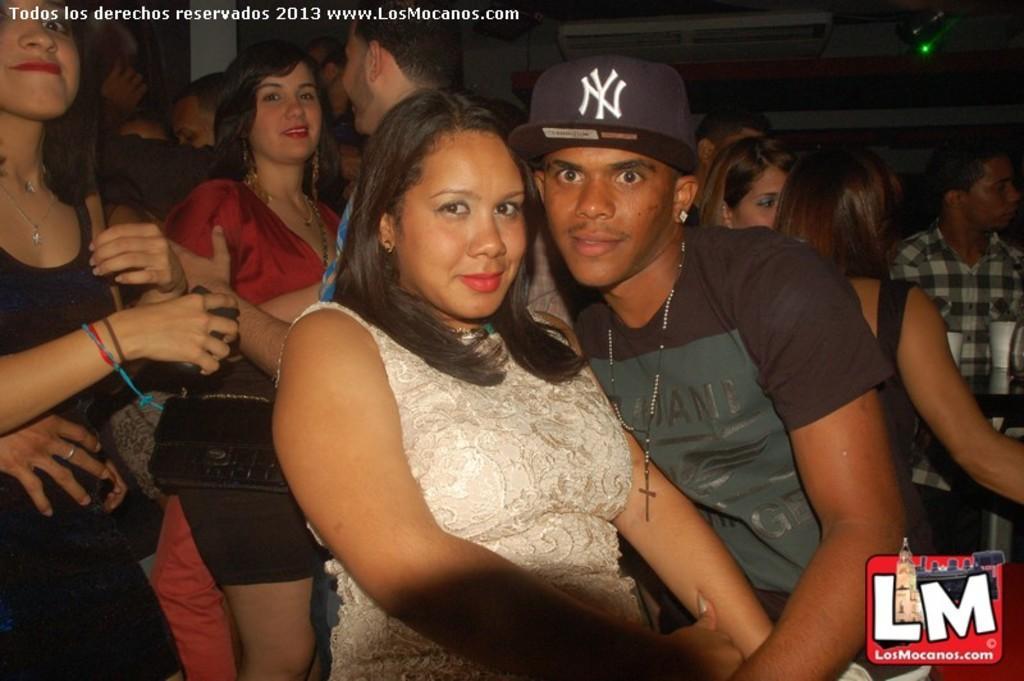In one or two sentences, can you explain what this image depicts? In this image we can see a group of people. 